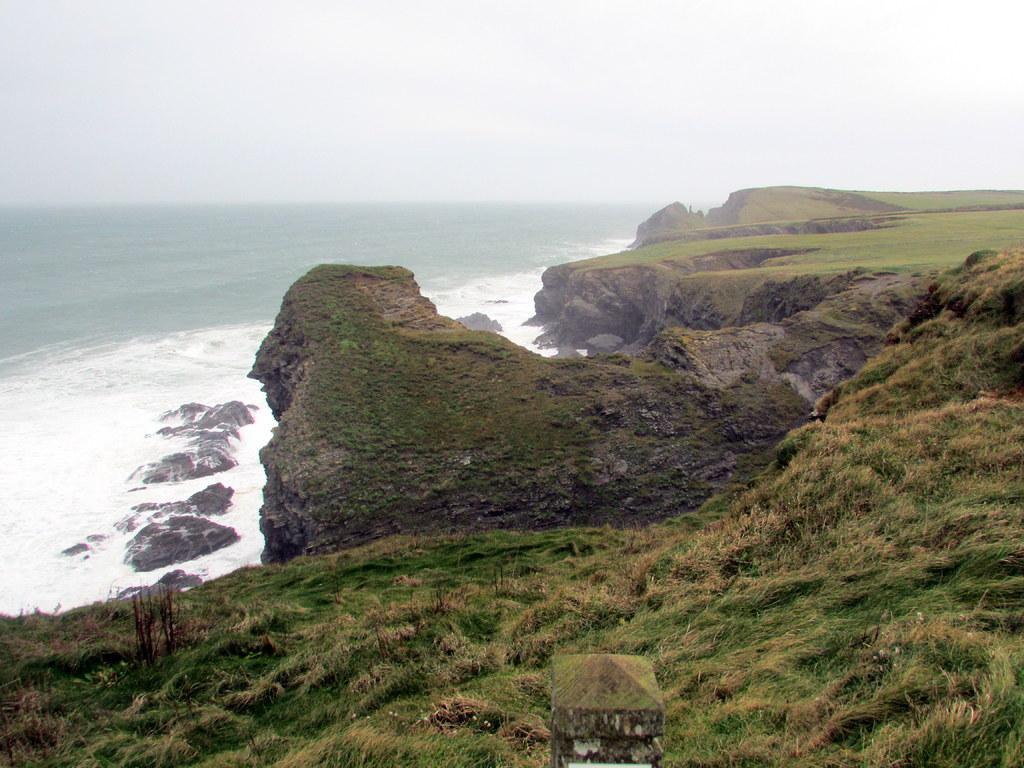How would you summarize this image in a sentence or two? In this image we can see water. Also there are rocks. On the ground there are plants. In the background there is sky. 